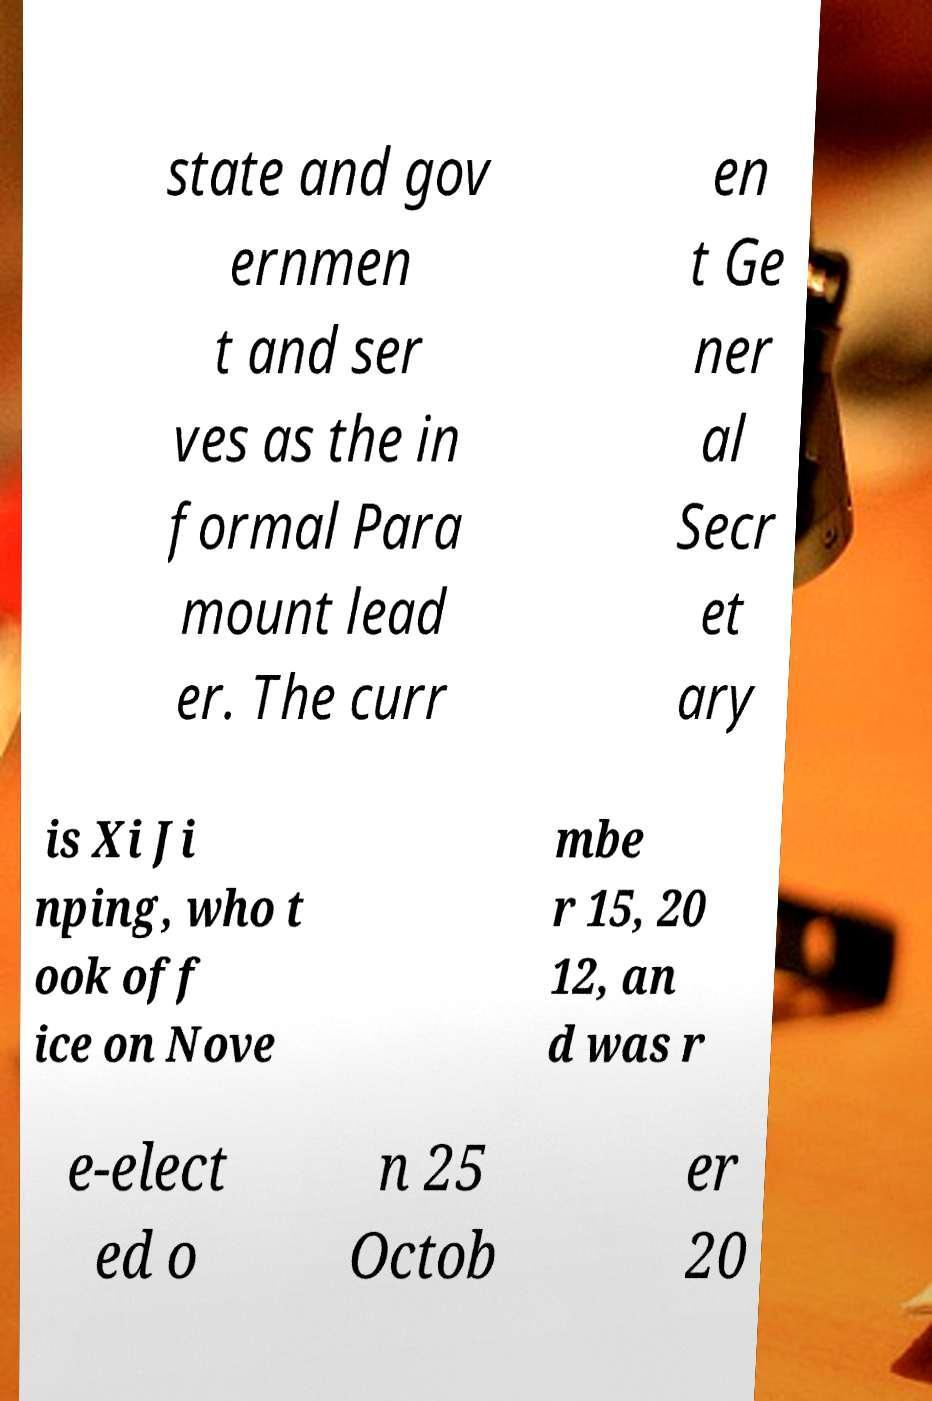Can you read and provide the text displayed in the image?This photo seems to have some interesting text. Can you extract and type it out for me? state and gov ernmen t and ser ves as the in formal Para mount lead er. The curr en t Ge ner al Secr et ary is Xi Ji nping, who t ook off ice on Nove mbe r 15, 20 12, an d was r e-elect ed o n 25 Octob er 20 